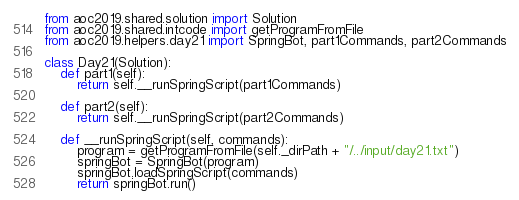<code> <loc_0><loc_0><loc_500><loc_500><_Python_>from aoc2019.shared.solution import Solution
from aoc2019.shared.intcode import getProgramFromFile
from aoc2019.helpers.day21 import SpringBot, part1Commands, part2Commands

class Day21(Solution):
    def part1(self):
        return self.__runSpringScript(part1Commands)

    def part2(self):
        return self.__runSpringScript(part2Commands)

    def __runSpringScript(self, commands):
        program = getProgramFromFile(self._dirPath + "/../input/day21.txt")
        springBot = SpringBot(program)
        springBot.loadSpringScript(commands)
        return springBot.run()
</code> 